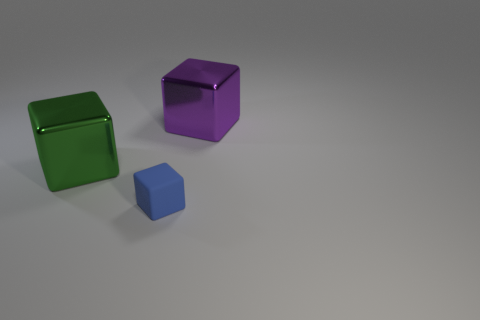Subtract all big blocks. How many blocks are left? 1 Subtract all green blocks. How many blocks are left? 2 Add 3 small blue rubber cubes. How many objects exist? 6 Add 2 small brown matte things. How many small brown matte things exist? 2 Subtract 0 blue balls. How many objects are left? 3 Subtract 1 cubes. How many cubes are left? 2 Subtract all cyan cubes. Subtract all blue spheres. How many cubes are left? 3 Subtract all blue cylinders. How many green blocks are left? 1 Subtract all large purple blocks. Subtract all big purple shiny objects. How many objects are left? 1 Add 1 small blue objects. How many small blue objects are left? 2 